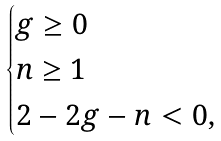Convert formula to latex. <formula><loc_0><loc_0><loc_500><loc_500>\begin{cases} g \geq 0 \\ n \geq 1 \\ 2 - 2 g - n < 0 , \end{cases}</formula> 